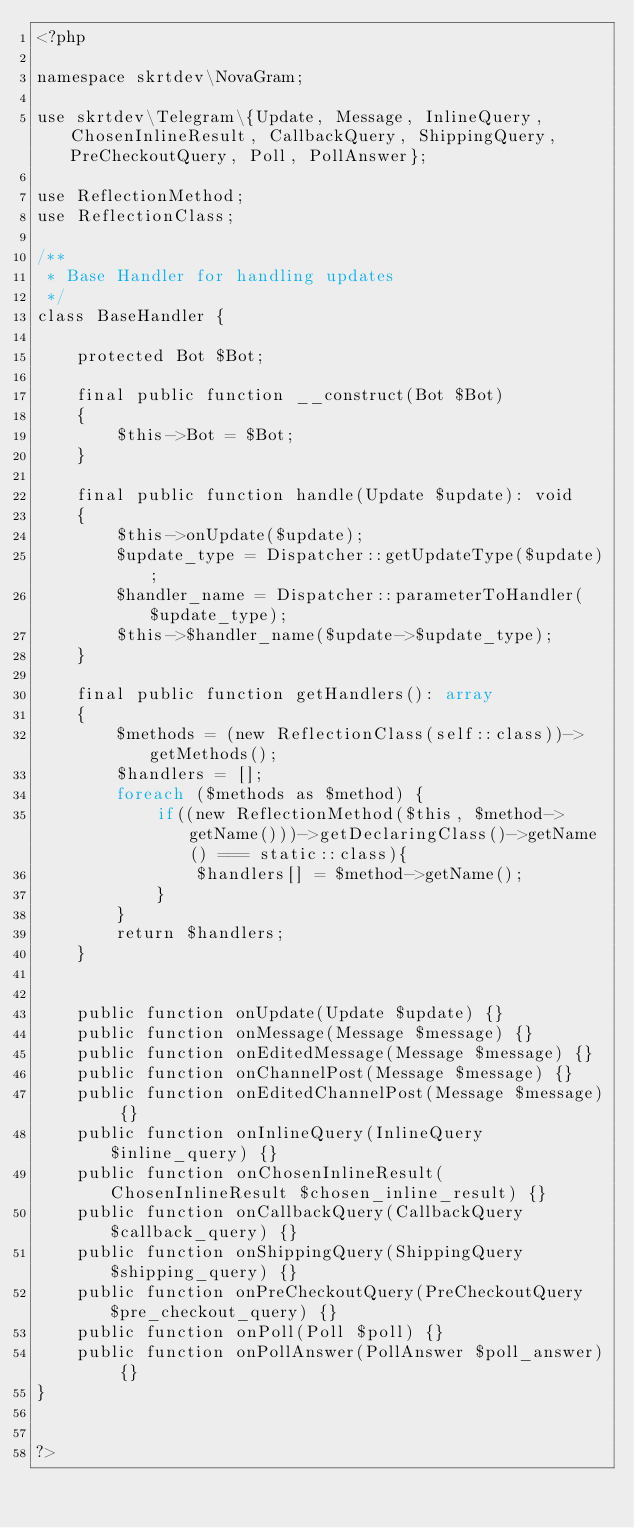Convert code to text. <code><loc_0><loc_0><loc_500><loc_500><_PHP_><?php

namespace skrtdev\NovaGram;

use skrtdev\Telegram\{Update, Message, InlineQuery, ChosenInlineResult, CallbackQuery, ShippingQuery, PreCheckoutQuery, Poll, PollAnswer};

use ReflectionMethod;
use ReflectionClass;

/**
 * Base Handler for handling updates
 */
class BaseHandler {

    protected Bot $Bot;

    final public function __construct(Bot $Bot)
    {
        $this->Bot = $Bot;
    }

    final public function handle(Update $update): void
    {
        $this->onUpdate($update);
        $update_type = Dispatcher::getUpdateType($update);
        $handler_name = Dispatcher::parameterToHandler($update_type);
        $this->$handler_name($update->$update_type);
    }

    final public function getHandlers(): array
    {
        $methods = (new ReflectionClass(self::class))->getMethods();
        $handlers = [];
        foreach ($methods as $method) {
            if((new ReflectionMethod($this, $method->getName()))->getDeclaringClass()->getName() === static::class){
                $handlers[] = $method->getName();
            }
        }
        return $handlers;
    }


    public function onUpdate(Update $update) {}
    public function onMessage(Message $message) {}
    public function onEditedMessage(Message $message) {}
    public function onChannelPost(Message $message) {}
    public function onEditedChannelPost(Message $message) {}
    public function onInlineQuery(InlineQuery $inline_query) {}
    public function onChosenInlineResult(ChosenInlineResult $chosen_inline_result) {}
    public function onCallbackQuery(CallbackQuery $callback_query) {}
    public function onShippingQuery(ShippingQuery $shipping_query) {}
    public function onPreCheckoutQuery(PreCheckoutQuery $pre_checkout_query) {}
    public function onPoll(Poll $poll) {}
    public function onPollAnswer(PollAnswer $poll_answer) {}
}


?>
</code> 